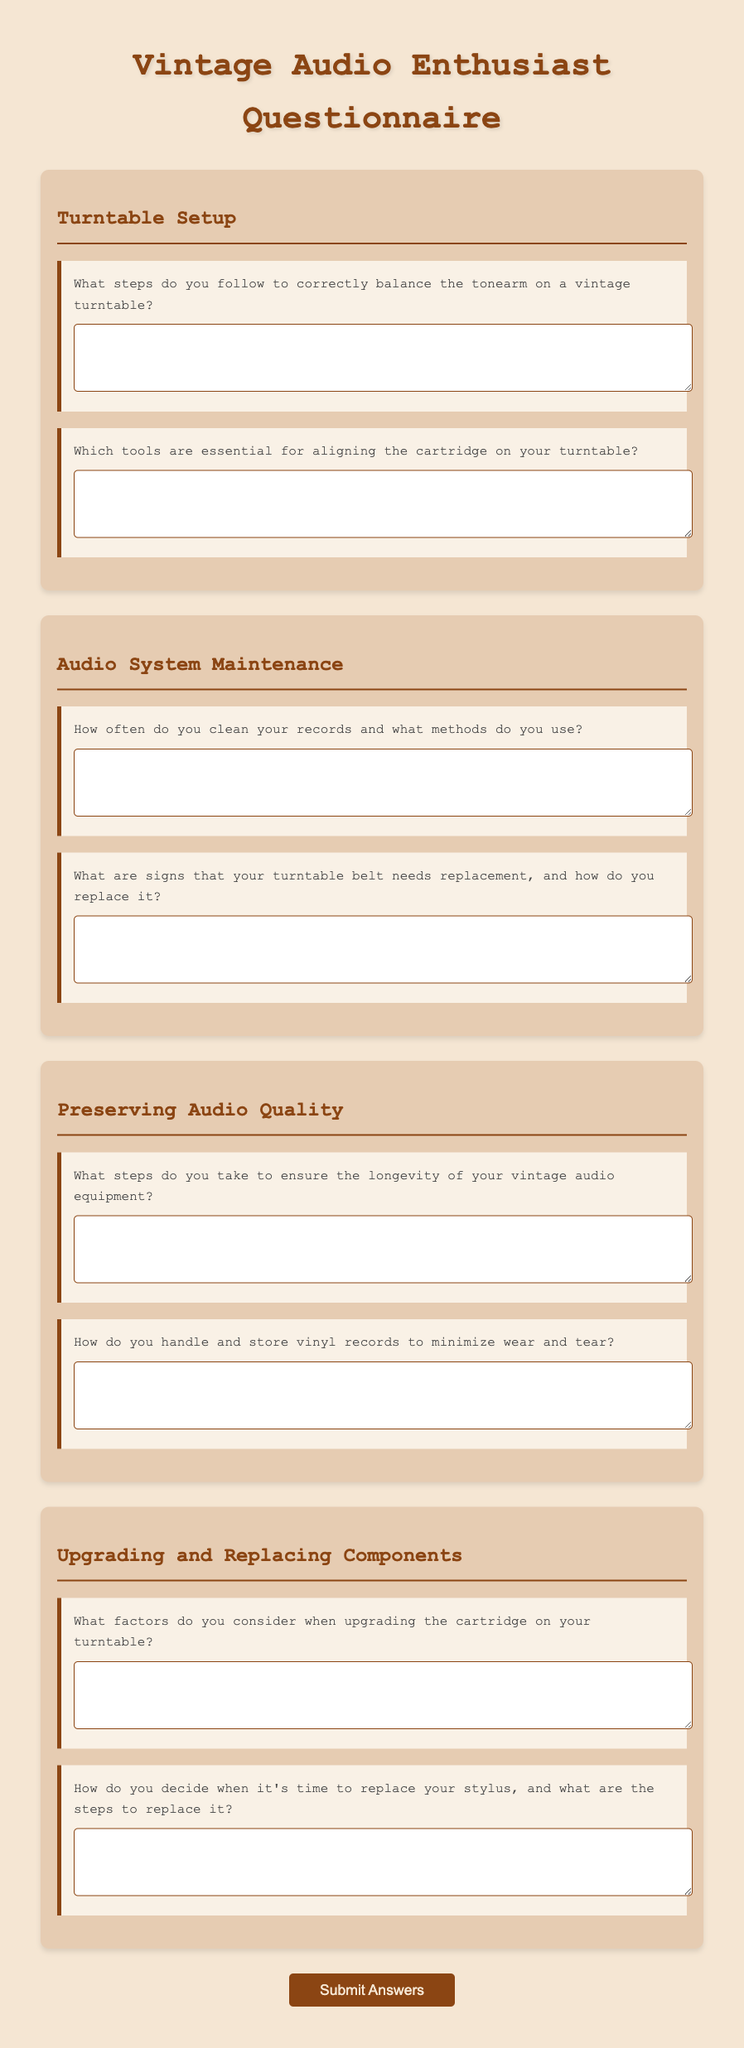What is the title of the questionnaire? The title is written at the top of the document and introduces the purpose of gathering information from vintage audio enthusiasts.
Answer: Vintage Audio Enthusiast Questionnaire What section covers the alignment of the cartridge? The section's heading indicates that it deals specifically with how to set up the turntable, including the cartridge.
Answer: Turntable Setup How many questions are there in the "Preserving Audio Quality" section? The document lists two questions under the section topic related to preserving audio quality.
Answer: 2 What is the label for the first question in the "Audio System Maintenance" section? The first question asks about the cleaning methods used for records and the frequency of cleaning.
Answer: How often do you clean your records and what methods do you use? What kind of button is used to submit the questionnaire? The button's style and function are described in the document, indicating it submits the user's filled questionnaire.
Answer: Submit Answers What action does the form trigger upon submission? The form has a script that prevents the default submission behavior and shows an alert confirming questionnaire completion.
Answer: Alert message What background color is used for the document's body? The background color is defined in the style section, which impacts the visual aesthetics of the document.
Answer: Light beige What happens when a question is hovered over? The document specifies an interactive effect that enhances user engagement when hovering over question elements.
Answer: It transforms and shows a box shadow 